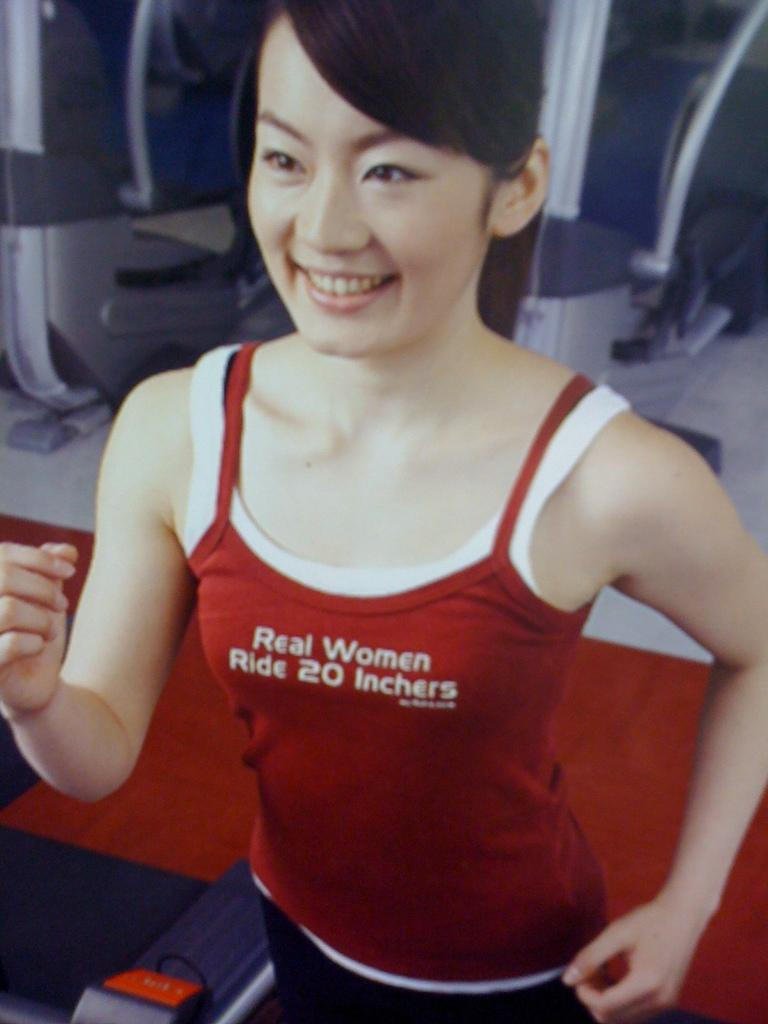<image>
Provide a brief description of the given image. A woman exercising with a tank top on that says Real Women Ride 20 Inchers. 